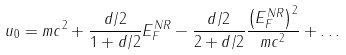<formula> <loc_0><loc_0><loc_500><loc_500>u _ { 0 } = m c ^ { 2 } + \frac { d / 2 } { 1 + d / 2 } E _ { F } ^ { N R } - \frac { d / 2 } { 2 + d / 2 } \frac { \left ( E _ { F } ^ { N R } \right ) ^ { 2 } } { m c ^ { 2 } } + \dots</formula> 